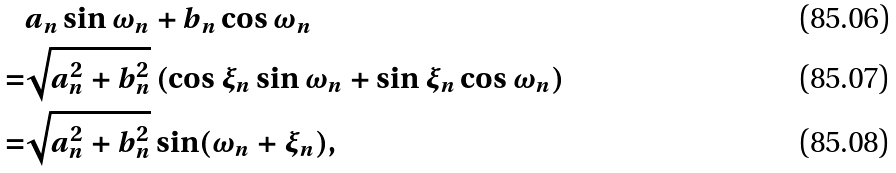Convert formula to latex. <formula><loc_0><loc_0><loc_500><loc_500>& a _ { n } \sin \omega _ { n } + b _ { n } \cos \omega _ { n } \\ = & \sqrt { a _ { n } ^ { 2 } + b _ { n } ^ { 2 } } \left ( \cos \xi _ { n } \sin \omega _ { n } + \sin \xi _ { n } \cos \omega _ { n } \right ) \\ = & \sqrt { a _ { n } ^ { 2 } + b _ { n } ^ { 2 } } \sin ( \omega _ { n } + \xi _ { n } ) ,</formula> 